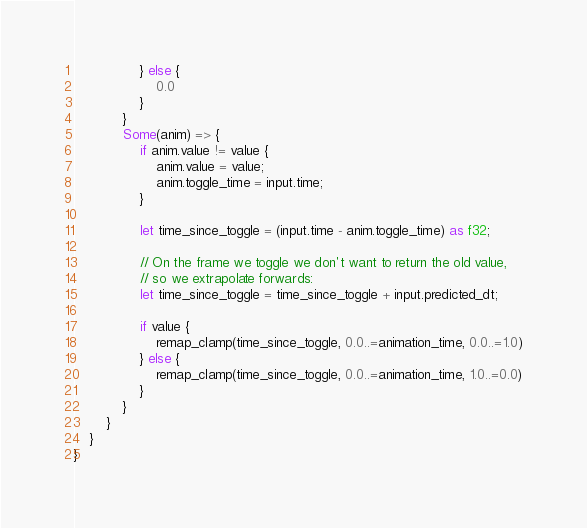<code> <loc_0><loc_0><loc_500><loc_500><_Rust_>                } else {
                    0.0
                }
            }
            Some(anim) => {
                if anim.value != value {
                    anim.value = value;
                    anim.toggle_time = input.time;
                }

                let time_since_toggle = (input.time - anim.toggle_time) as f32;

                // On the frame we toggle we don't want to return the old value,
                // so we extrapolate forwards:
                let time_since_toggle = time_since_toggle + input.predicted_dt;

                if value {
                    remap_clamp(time_since_toggle, 0.0..=animation_time, 0.0..=1.0)
                } else {
                    remap_clamp(time_since_toggle, 0.0..=animation_time, 1.0..=0.0)
                }
            }
        }
    }
}
</code> 